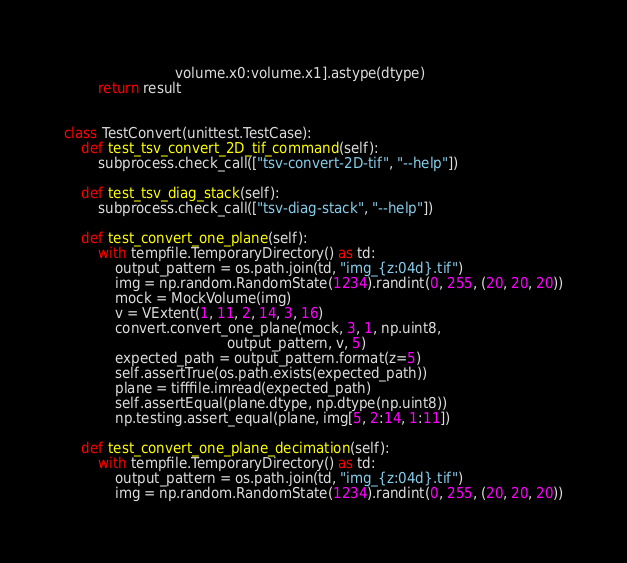<code> <loc_0><loc_0><loc_500><loc_500><_Python_>                          volume.x0:volume.x1].astype(dtype)
        return result


class TestConvert(unittest.TestCase):
    def test_tsv_convert_2D_tif_command(self):
        subprocess.check_call(["tsv-convert-2D-tif", "--help"])

    def test_tsv_diag_stack(self):
        subprocess.check_call(["tsv-diag-stack", "--help"])

    def test_convert_one_plane(self):
        with tempfile.TemporaryDirectory() as td:
            output_pattern = os.path.join(td, "img_{z:04d}.tif")
            img = np.random.RandomState(1234).randint(0, 255, (20, 20, 20))
            mock = MockVolume(img)
            v = VExtent(1, 11, 2, 14, 3, 16)
            convert.convert_one_plane(mock, 3, 1, np.uint8,
                                      output_pattern, v, 5)
            expected_path = output_pattern.format(z=5)
            self.assertTrue(os.path.exists(expected_path))
            plane = tifffile.imread(expected_path)
            self.assertEqual(plane.dtype, np.dtype(np.uint8))
            np.testing.assert_equal(plane, img[5, 2:14, 1:11])

    def test_convert_one_plane_decimation(self):
        with tempfile.TemporaryDirectory() as td:
            output_pattern = os.path.join(td, "img_{z:04d}.tif")
            img = np.random.RandomState(1234).randint(0, 255, (20, 20, 20))</code> 